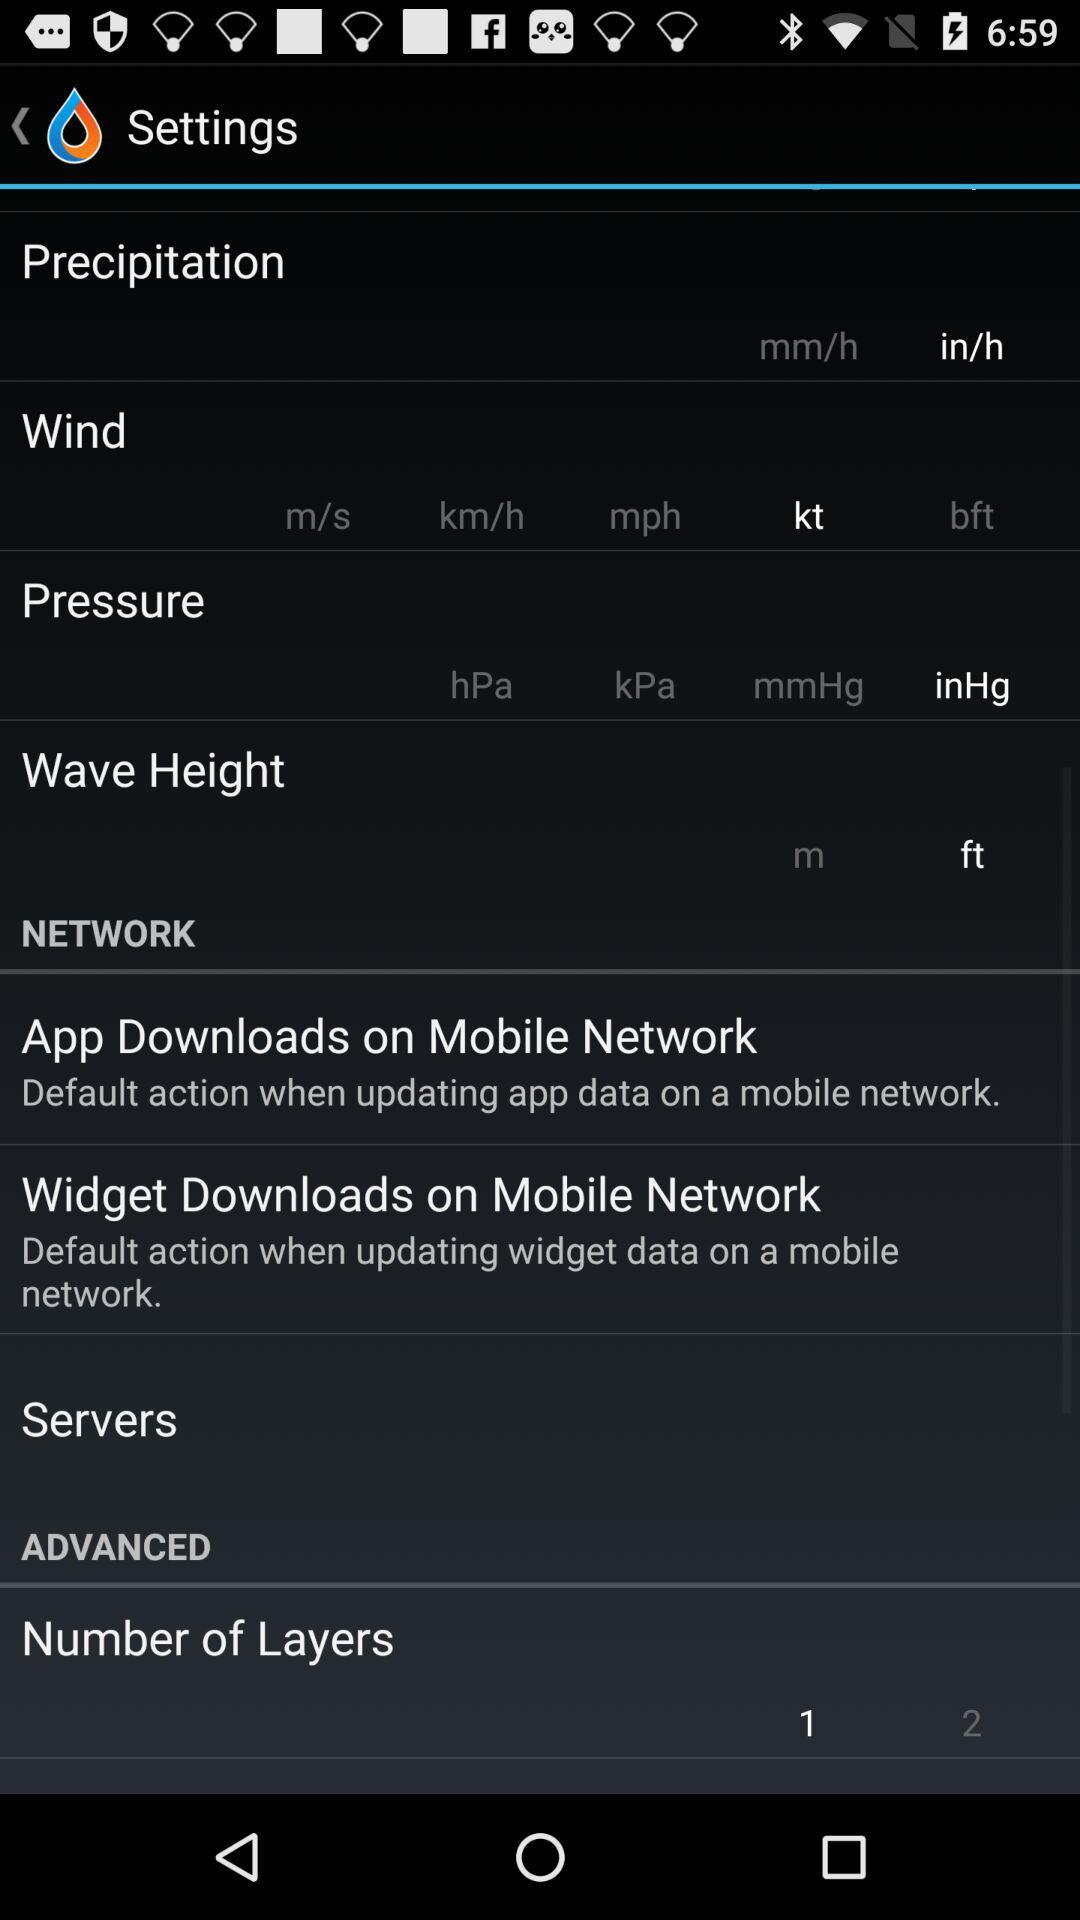How many layers are there?
Answer the question using a single word or phrase. 2 